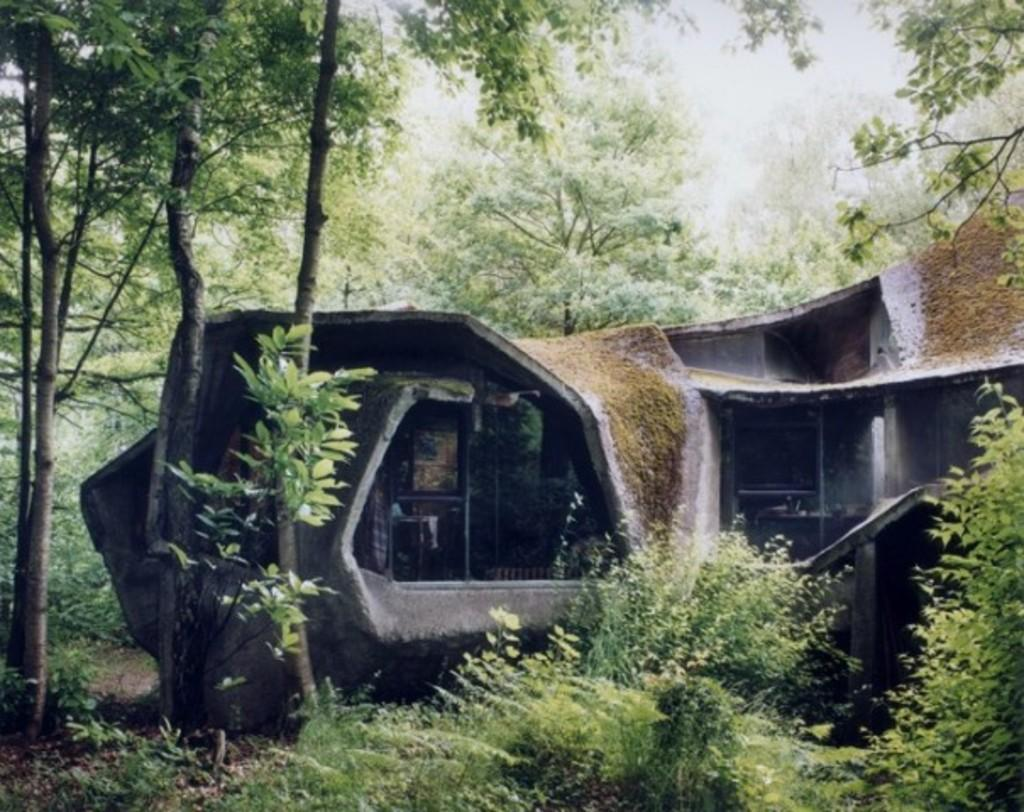What type of structure is present in the image? There is a building in the image. What feature can be observed on the building? The building has windows. What type of natural vegetation is visible in the image? There are trees visible in the image. Where is the hydrant located in the image? There is no hydrant present in the image. What type of stamp can be seen on the building in the image? There is no stamp present on the building in the image. 